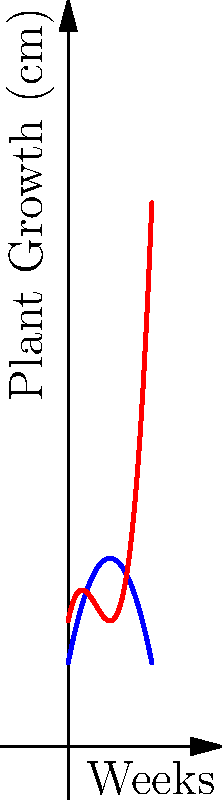In our community garden, we're planning to grow tomatoes and carrots. The graph shows the growth patterns of these vegetables over 10 weeks. The blue curve represents tomatoes, and the red curve represents carrots. At which week do both plants reach the same height, and what is that height? To solve this problem, we need to find the intersection point of the two polynomial curves. Let's approach this step-by-step:

1. The blue curve (tomatoes) is represented by the equation:
   $$f(x) = -0.5x^2 + 5x + 10$$

2. The red curve (carrots) is represented by the equation:
   $$g(x) = 0.2x^3 - 2x^2 + 5x + 15$$

3. To find the intersection point, we need to solve the equation:
   $$f(x) = g(x)$$

4. Substituting the equations:
   $$-0.5x^2 + 5x + 10 = 0.2x^3 - 2x^2 + 5x + 15$$

5. Simplifying:
   $$0.2x^3 - 1.5x^2 - 5 = 0$$

6. This cubic equation can be solved using a graphing calculator or computer algebra system. The solution relevant to our 10-week period is approximately:
   $$x \approx 4.65$$

7. Substituting this value back into either equation gives us the height:
   $$f(4.65) \approx g(4.65) \approx 26.5$$

Therefore, both plants reach the same height at approximately 4.65 weeks, and the height is about 26.5 cm.
Answer: 4.65 weeks, 26.5 cm 